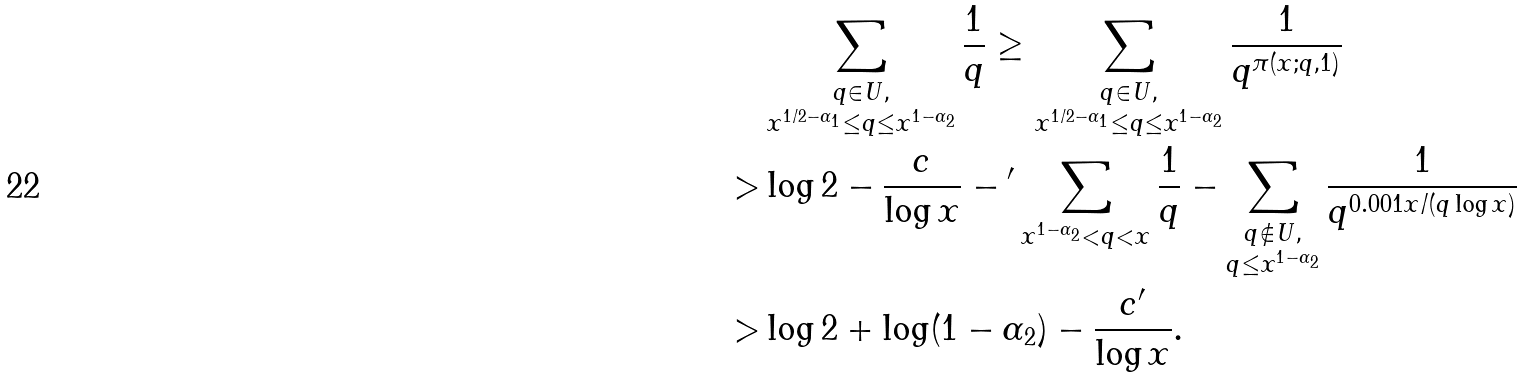<formula> <loc_0><loc_0><loc_500><loc_500>& \sum _ { \substack { q \in U , \\ x ^ { 1 / 2 - \alpha _ { 1 } } \leq q \leq x ^ { 1 - \alpha _ { 2 } } } } \frac { 1 } { q } \geq \sum _ { \substack { q \in U , \\ x ^ { 1 / 2 - \alpha _ { 1 } } \leq q \leq x ^ { 1 - \alpha _ { 2 } } } } \frac { 1 } { q ^ { \pi ( x ; q , 1 ) } } \\ > & \log 2 - \frac { c } { \log x } - { ^ { \prime } } \sum _ { x ^ { 1 - \alpha _ { 2 } } < q < x } \frac { 1 } { q } - \sum _ { \substack { q \not \in U , \\ q \leq x ^ { 1 - \alpha _ { 2 } } } } \frac { 1 } { q ^ { 0 . 0 0 1 x / ( q \log x ) } } \\ > & \log 2 + \log ( 1 - \alpha _ { 2 } ) - \frac { c ^ { \prime } } { \log x } .</formula> 